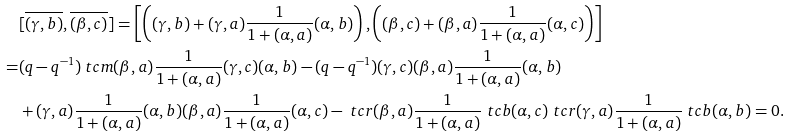<formula> <loc_0><loc_0><loc_500><loc_500>& [ \overline { ( \gamma , b ) } , \overline { ( \beta , c ) } ] = \left [ \left ( ( \gamma , b ) + ( \gamma , a ) \frac { 1 } { 1 + ( \alpha , a ) } ( \alpha , b ) \right ) , \left ( ( \beta , c ) + ( \beta , a ) \frac { 1 } { 1 + ( \alpha , a ) } ( \alpha , c ) \right ) \right ] \\ = & ( q - q ^ { - 1 } ) \ t c m { ( \beta , a ) \frac { 1 } { 1 + ( \alpha , a ) } ( \gamma , c ) } ( \alpha , b ) - ( q - q ^ { - 1 } ) ( \gamma , c ) ( \beta , a ) \frac { 1 } { 1 + ( \alpha , a ) } ( \alpha , b ) \\ & + ( \gamma , a ) \frac { 1 } { 1 + ( \alpha , a ) } ( \alpha , b ) ( \beta , a ) \frac { 1 } { 1 + ( \alpha , a ) } ( \alpha , c ) - \ t c r { ( \beta , a ) } \frac { 1 } { 1 + ( \alpha , a ) } \ t c b { ( \alpha , c ) } \ t c r { ( \gamma , a ) } \frac { 1 } { 1 + ( \alpha , a ) } \ t c b { ( \alpha , b ) } = 0 .</formula> 